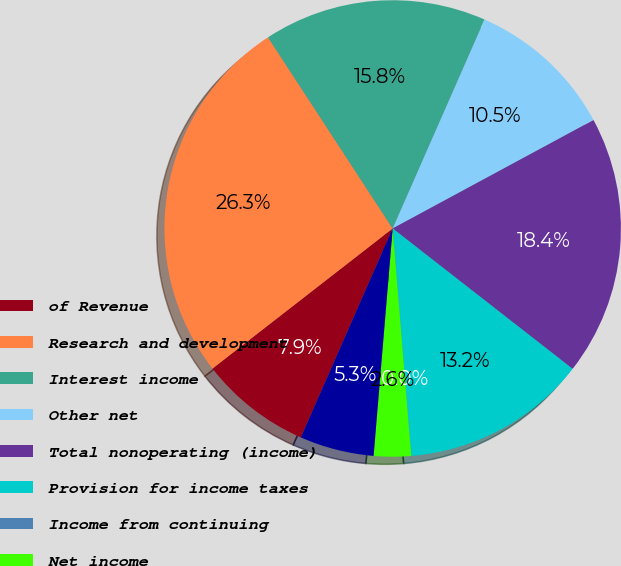Convert chart. <chart><loc_0><loc_0><loc_500><loc_500><pie_chart><fcel>of Revenue<fcel>Research and development<fcel>Interest income<fcel>Other net<fcel>Total nonoperating (income)<fcel>Provision for income taxes<fcel>Income from continuing<fcel>Net income<fcel>Dividends declared per share<nl><fcel>7.89%<fcel>26.32%<fcel>15.79%<fcel>10.53%<fcel>18.42%<fcel>13.16%<fcel>0.0%<fcel>2.63%<fcel>5.26%<nl></chart> 